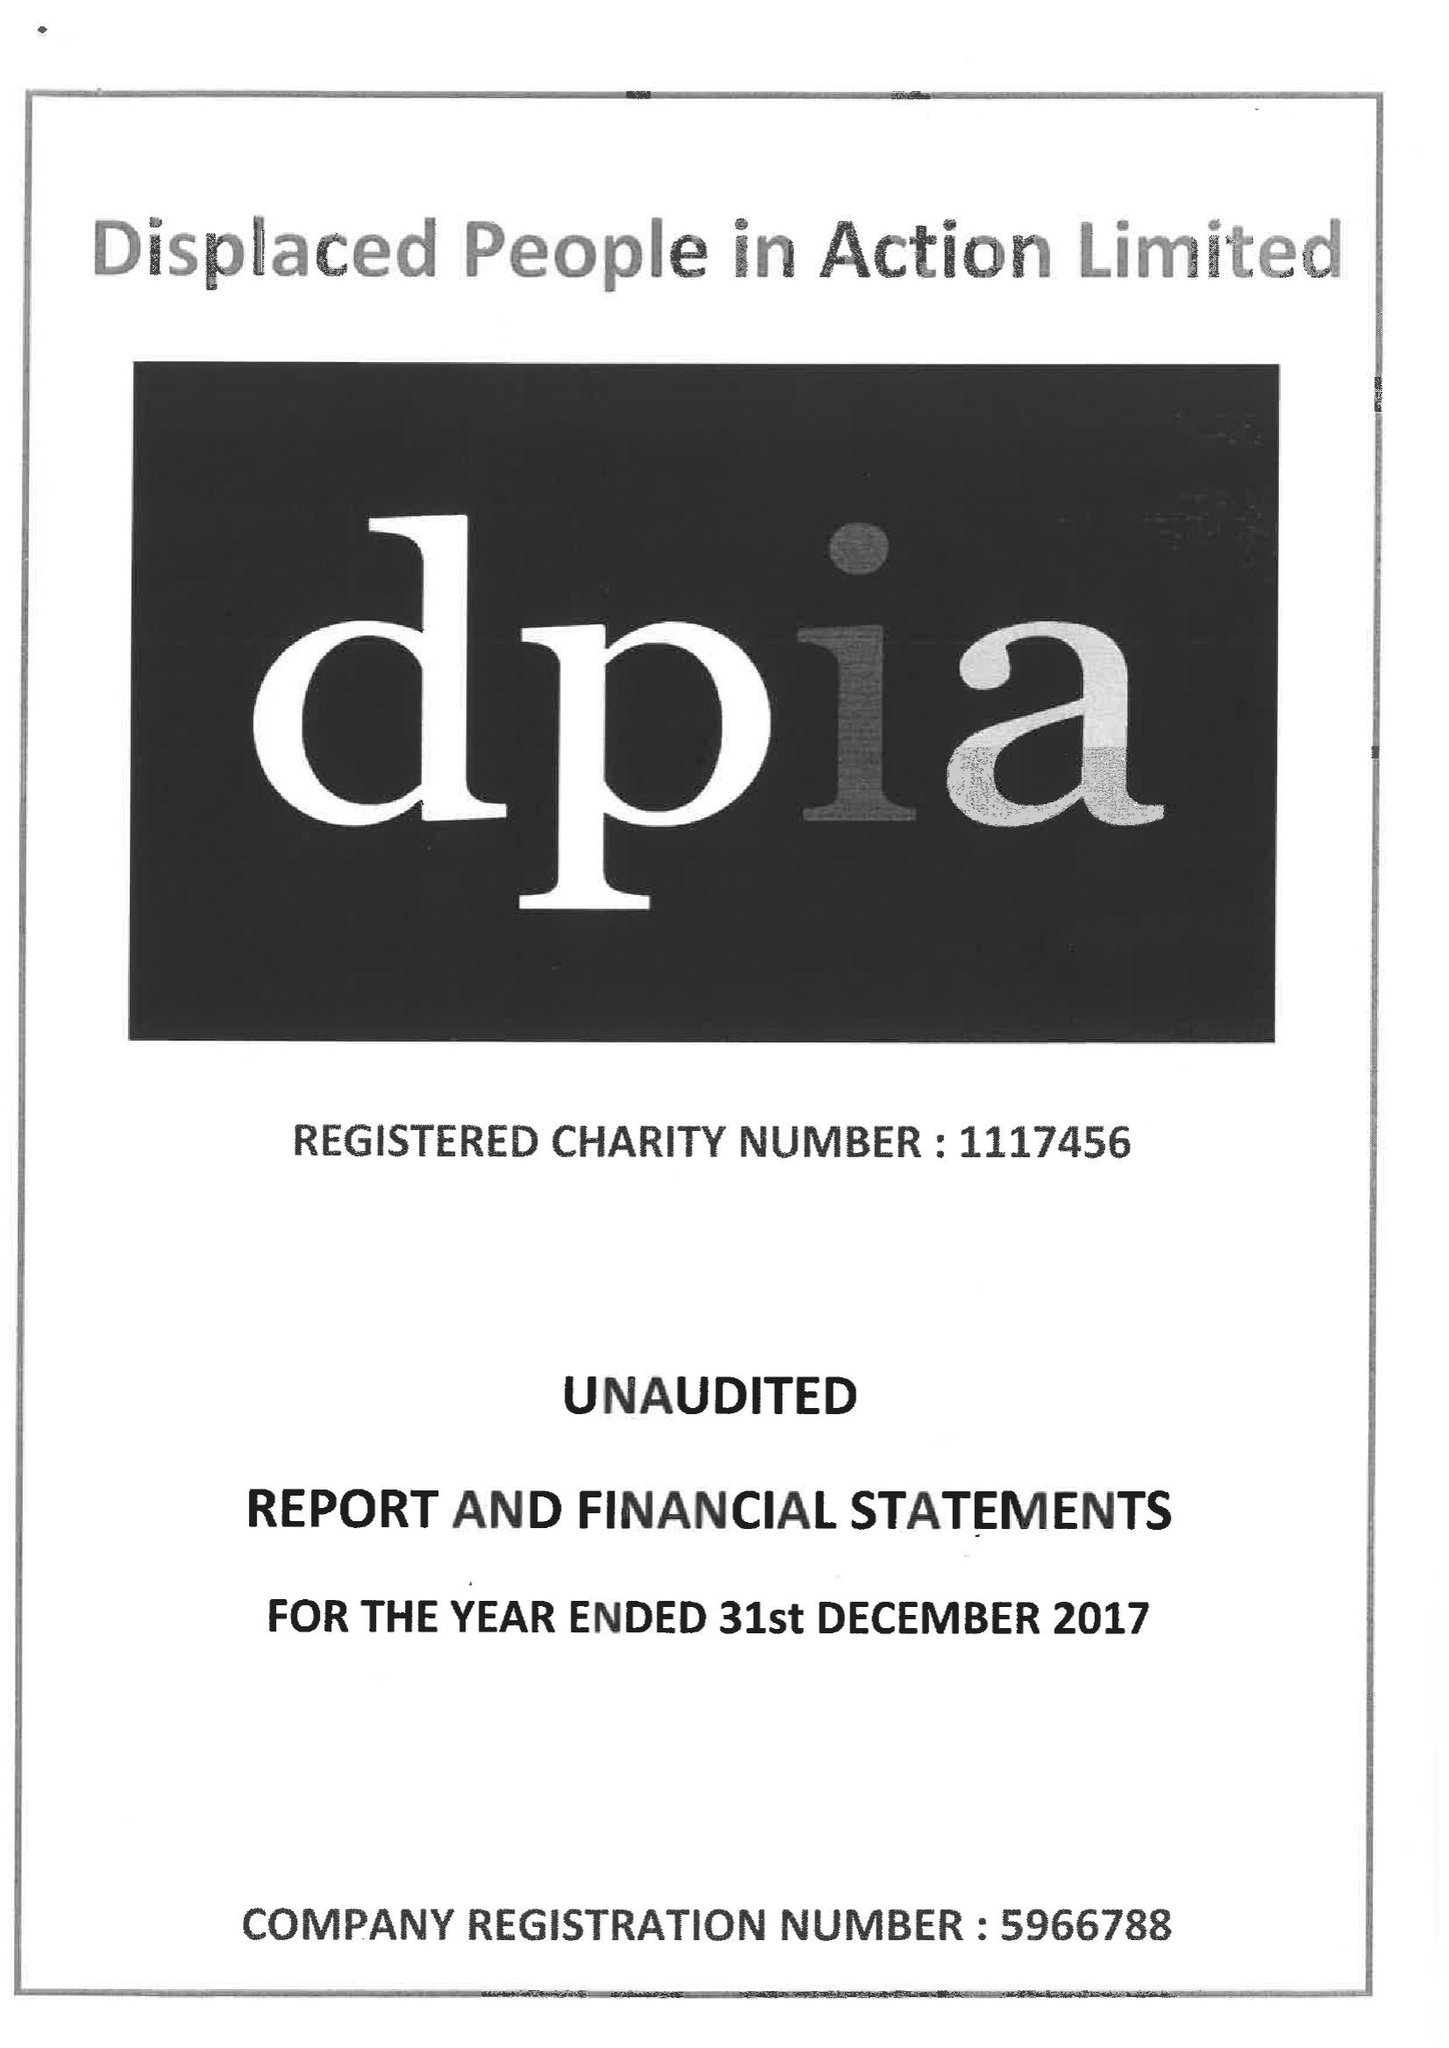What is the value for the address__postcode?
Answer the question using a single word or phrase. CF24 0BL 